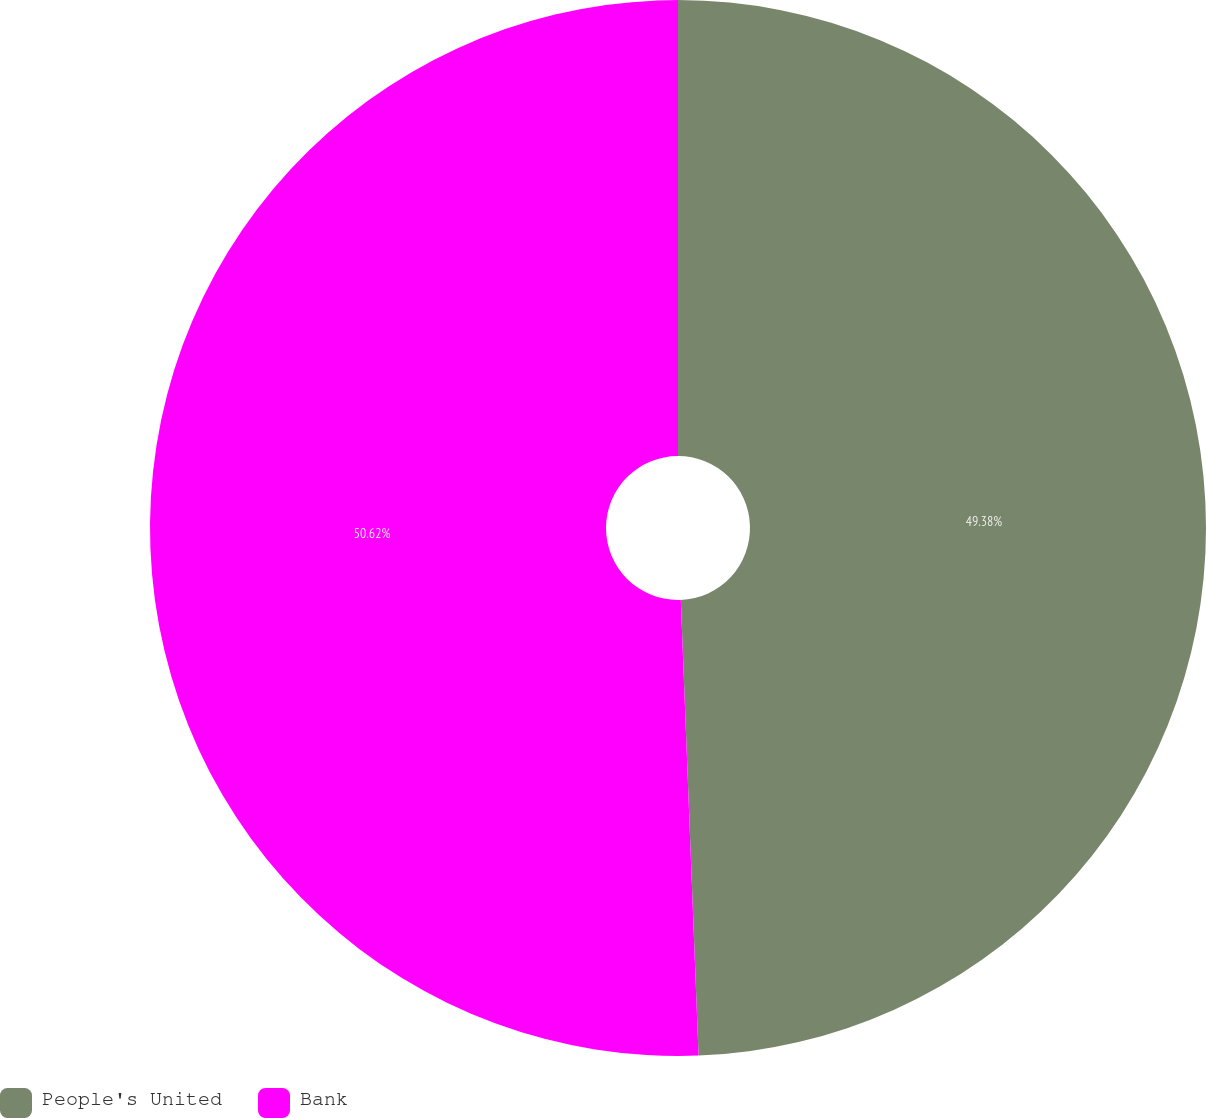Convert chart to OTSL. <chart><loc_0><loc_0><loc_500><loc_500><pie_chart><fcel>People's United<fcel>Bank<nl><fcel>49.38%<fcel>50.62%<nl></chart> 